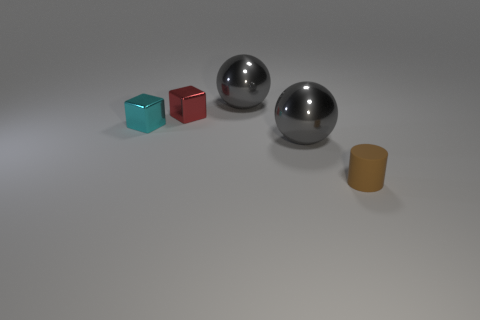Subtract all purple balls. Subtract all brown cylinders. How many balls are left? 2 Subtract all brown cylinders. How many purple blocks are left? 0 Add 1 small cyans. How many grays exist? 0 Subtract all small matte objects. Subtract all small brown rubber cylinders. How many objects are left? 3 Add 4 tiny cyan metallic cubes. How many tiny cyan metallic cubes are left? 5 Add 2 large metal spheres. How many large metal spheres exist? 4 Add 2 small things. How many objects exist? 7 Subtract all cyan cubes. How many cubes are left? 1 Subtract 0 red spheres. How many objects are left? 5 Subtract all gray balls. How many were subtracted if there are1gray balls left? 1 